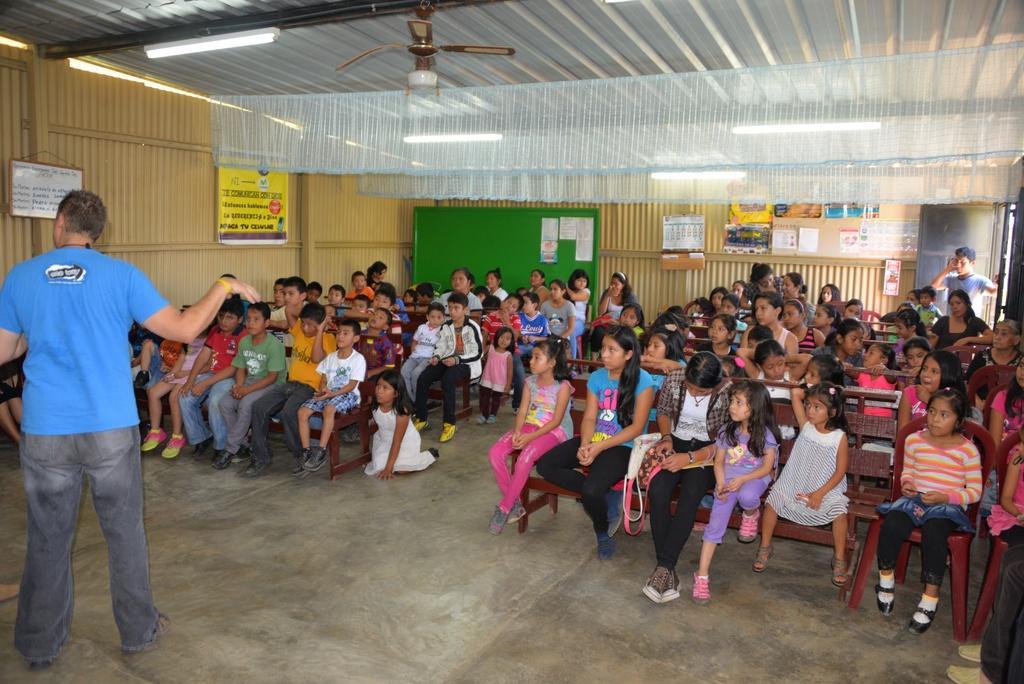How would you summarize this image in a sentence or two? In this image in the room there are many kids sitting on the benches. In the left a man is standing wearing blue t-shirt. On the wall there are boards, papers. On the ceiling there are fans , lights. Here a person is standing. 